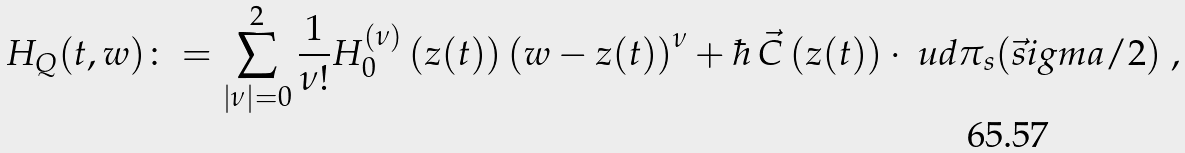<formula> <loc_0><loc_0><loc_500><loc_500>H _ { Q } ( t , w ) \colon = \sum _ { | \nu | = 0 } ^ { 2 } \frac { 1 } { \nu ! } H _ { 0 } ^ { ( \nu ) } \left ( z ( t ) \right ) \left ( w - z ( t ) \right ) ^ { \nu } + \hbar { \, } \vec { C } \left ( z ( t ) \right ) \cdot \ u d \pi _ { s } ( \vec { s } i g m a / 2 ) \ ,</formula> 